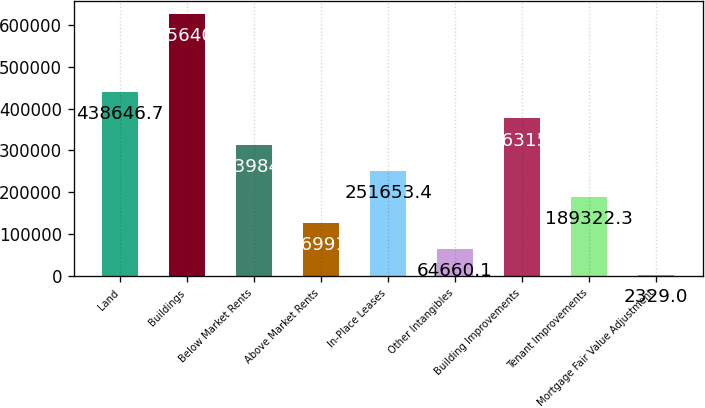Convert chart. <chart><loc_0><loc_0><loc_500><loc_500><bar_chart><fcel>Land<fcel>Buildings<fcel>Below Market Rents<fcel>Above Market Rents<fcel>In-Place Leases<fcel>Other Intangibles<fcel>Building Improvements<fcel>Tenant Improvements<fcel>Mortgage Fair Value Adjustment<nl><fcel>438647<fcel>625640<fcel>313984<fcel>126991<fcel>251653<fcel>64660.1<fcel>376316<fcel>189322<fcel>2329<nl></chart> 